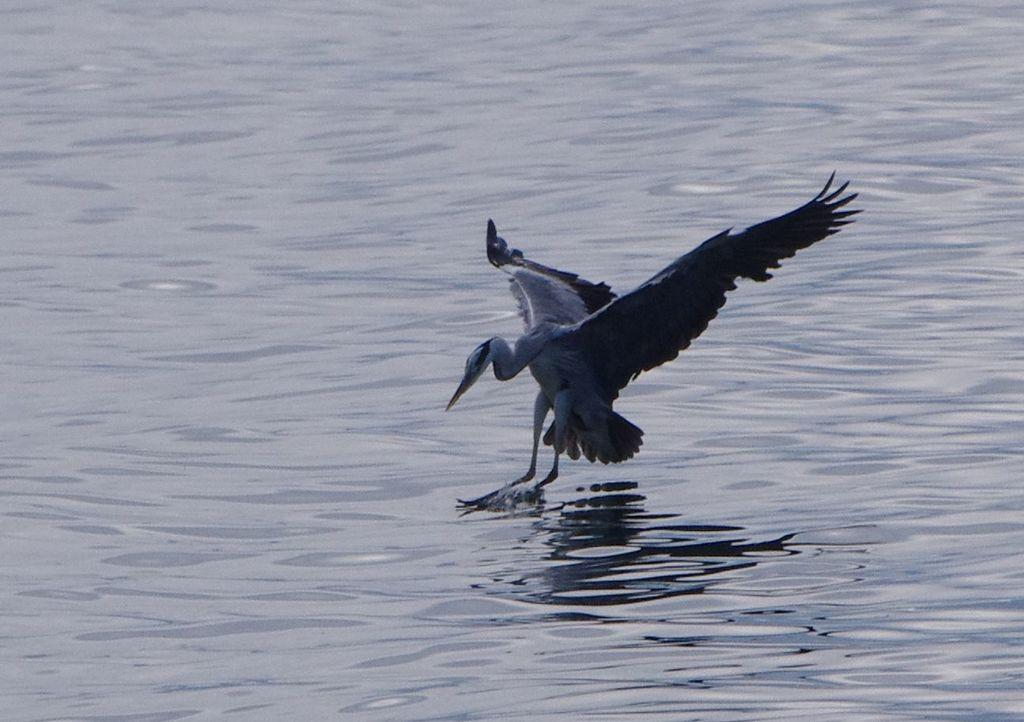What type of animal is in the image? There is a bird in the image. Where is the bird located? The bird is on the water. What is the bird's income in the image? There is no information about the bird's income in the image, as birds do not have incomes. 